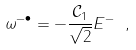Convert formula to latex. <formula><loc_0><loc_0><loc_500><loc_500>\omega ^ { - \bullet } = - \frac { \mathcal { C } _ { 1 } } { \sqrt { 2 } } E ^ { - } \ ,</formula> 